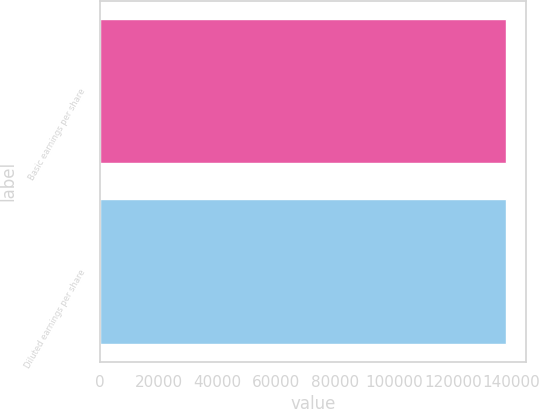Convert chart. <chart><loc_0><loc_0><loc_500><loc_500><bar_chart><fcel>Basic earnings per share<fcel>Diluted earnings per share<nl><fcel>137943<fcel>137943<nl></chart> 